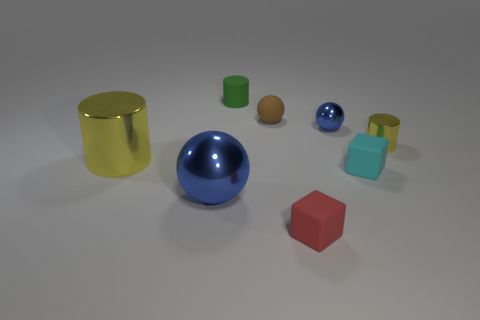Add 1 big gray shiny balls. How many objects exist? 9 Subtract all tiny matte cylinders. How many cylinders are left? 2 Subtract all cubes. How many objects are left? 6 Subtract all red blocks. Subtract all brown spheres. How many blocks are left? 1 Subtract all gray cylinders. How many blue blocks are left? 0 Subtract all small blue shiny things. Subtract all green matte things. How many objects are left? 6 Add 5 small brown matte balls. How many small brown matte balls are left? 6 Add 6 large yellow metal things. How many large yellow metal things exist? 7 Subtract all green cylinders. How many cylinders are left? 2 Subtract 0 purple spheres. How many objects are left? 8 